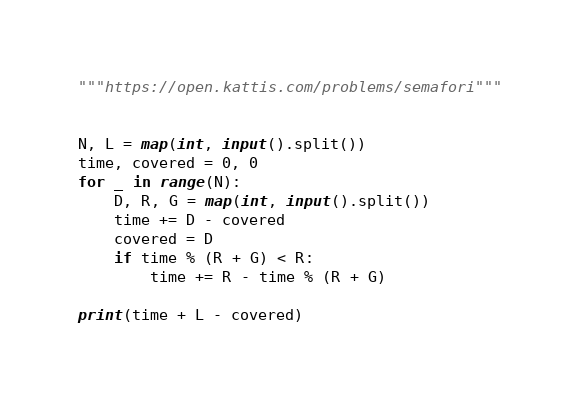Convert code to text. <code><loc_0><loc_0><loc_500><loc_500><_Python_>"""https://open.kattis.com/problems/semafori"""


N, L = map(int, input().split())
time, covered = 0, 0
for _ in range(N):
    D, R, G = map(int, input().split())
    time += D - covered
    covered = D
    if time % (R + G) < R:
        time += R - time % (R + G)

print(time + L - covered)
</code> 